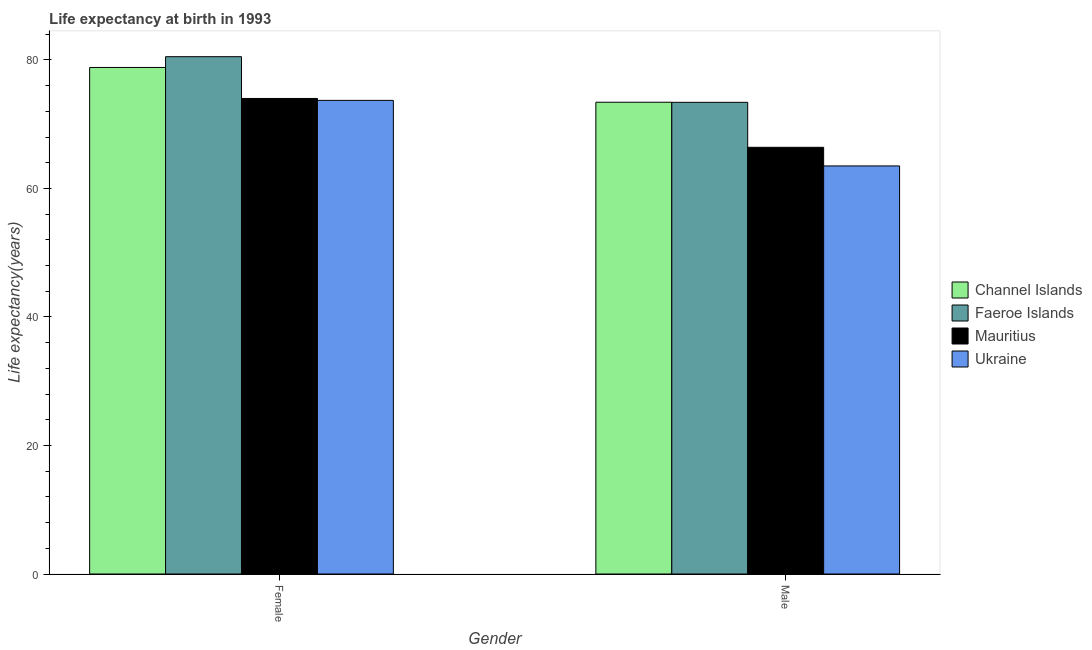How many groups of bars are there?
Your response must be concise. 2. Are the number of bars per tick equal to the number of legend labels?
Your response must be concise. Yes. Are the number of bars on each tick of the X-axis equal?
Offer a very short reply. Yes. How many bars are there on the 1st tick from the left?
Keep it short and to the point. 4. How many bars are there on the 1st tick from the right?
Offer a very short reply. 4. What is the life expectancy(female) in Ukraine?
Your response must be concise. 73.7. Across all countries, what is the maximum life expectancy(female)?
Ensure brevity in your answer.  80.5. Across all countries, what is the minimum life expectancy(female)?
Offer a terse response. 73.7. In which country was the life expectancy(male) maximum?
Give a very brief answer. Channel Islands. In which country was the life expectancy(male) minimum?
Offer a terse response. Ukraine. What is the total life expectancy(male) in the graph?
Keep it short and to the point. 276.71. What is the difference between the life expectancy(male) in Ukraine and that in Faeroe Islands?
Provide a succinct answer. -9.9. What is the difference between the life expectancy(male) in Mauritius and the life expectancy(female) in Channel Islands?
Keep it short and to the point. -12.42. What is the average life expectancy(female) per country?
Provide a succinct answer. 76.76. What is the difference between the life expectancy(female) and life expectancy(male) in Faeroe Islands?
Offer a terse response. 7.1. In how many countries, is the life expectancy(male) greater than 20 years?
Provide a short and direct response. 4. What is the ratio of the life expectancy(female) in Mauritius to that in Ukraine?
Keep it short and to the point. 1. What does the 3rd bar from the left in Male represents?
Make the answer very short. Mauritius. What does the 4th bar from the right in Male represents?
Provide a succinct answer. Channel Islands. How many countries are there in the graph?
Provide a succinct answer. 4. What is the difference between two consecutive major ticks on the Y-axis?
Provide a short and direct response. 20. Are the values on the major ticks of Y-axis written in scientific E-notation?
Provide a succinct answer. No. How many legend labels are there?
Offer a very short reply. 4. How are the legend labels stacked?
Your answer should be compact. Vertical. What is the title of the graph?
Provide a succinct answer. Life expectancy at birth in 1993. What is the label or title of the X-axis?
Ensure brevity in your answer.  Gender. What is the label or title of the Y-axis?
Give a very brief answer. Life expectancy(years). What is the Life expectancy(years) in Channel Islands in Female?
Provide a succinct answer. 78.83. What is the Life expectancy(years) of Faeroe Islands in Female?
Provide a succinct answer. 80.5. What is the Life expectancy(years) in Ukraine in Female?
Give a very brief answer. 73.7. What is the Life expectancy(years) of Channel Islands in Male?
Make the answer very short. 73.41. What is the Life expectancy(years) of Faeroe Islands in Male?
Offer a very short reply. 73.4. What is the Life expectancy(years) in Mauritius in Male?
Your answer should be very brief. 66.4. What is the Life expectancy(years) of Ukraine in Male?
Your response must be concise. 63.5. Across all Gender, what is the maximum Life expectancy(years) of Channel Islands?
Provide a succinct answer. 78.83. Across all Gender, what is the maximum Life expectancy(years) in Faeroe Islands?
Keep it short and to the point. 80.5. Across all Gender, what is the maximum Life expectancy(years) in Ukraine?
Give a very brief answer. 73.7. Across all Gender, what is the minimum Life expectancy(years) of Channel Islands?
Keep it short and to the point. 73.41. Across all Gender, what is the minimum Life expectancy(years) of Faeroe Islands?
Provide a succinct answer. 73.4. Across all Gender, what is the minimum Life expectancy(years) in Mauritius?
Make the answer very short. 66.4. Across all Gender, what is the minimum Life expectancy(years) of Ukraine?
Your response must be concise. 63.5. What is the total Life expectancy(years) of Channel Islands in the graph?
Provide a short and direct response. 152.24. What is the total Life expectancy(years) of Faeroe Islands in the graph?
Keep it short and to the point. 153.9. What is the total Life expectancy(years) in Mauritius in the graph?
Provide a succinct answer. 140.4. What is the total Life expectancy(years) of Ukraine in the graph?
Your response must be concise. 137.2. What is the difference between the Life expectancy(years) of Channel Islands in Female and that in Male?
Keep it short and to the point. 5.41. What is the difference between the Life expectancy(years) in Ukraine in Female and that in Male?
Your answer should be very brief. 10.2. What is the difference between the Life expectancy(years) in Channel Islands in Female and the Life expectancy(years) in Faeroe Islands in Male?
Offer a terse response. 5.42. What is the difference between the Life expectancy(years) of Channel Islands in Female and the Life expectancy(years) of Mauritius in Male?
Your answer should be compact. 12.43. What is the difference between the Life expectancy(years) in Channel Islands in Female and the Life expectancy(years) in Ukraine in Male?
Ensure brevity in your answer.  15.32. What is the average Life expectancy(years) of Channel Islands per Gender?
Your answer should be very brief. 76.12. What is the average Life expectancy(years) of Faeroe Islands per Gender?
Offer a very short reply. 76.95. What is the average Life expectancy(years) of Mauritius per Gender?
Give a very brief answer. 70.2. What is the average Life expectancy(years) of Ukraine per Gender?
Make the answer very short. 68.6. What is the difference between the Life expectancy(years) of Channel Islands and Life expectancy(years) of Faeroe Islands in Female?
Provide a succinct answer. -1.68. What is the difference between the Life expectancy(years) in Channel Islands and Life expectancy(years) in Mauritius in Female?
Provide a short and direct response. 4.83. What is the difference between the Life expectancy(years) of Channel Islands and Life expectancy(years) of Ukraine in Female?
Give a very brief answer. 5.12. What is the difference between the Life expectancy(years) of Faeroe Islands and Life expectancy(years) of Mauritius in Female?
Offer a terse response. 6.5. What is the difference between the Life expectancy(years) of Mauritius and Life expectancy(years) of Ukraine in Female?
Give a very brief answer. 0.3. What is the difference between the Life expectancy(years) in Channel Islands and Life expectancy(years) in Faeroe Islands in Male?
Your answer should be compact. 0.01. What is the difference between the Life expectancy(years) of Channel Islands and Life expectancy(years) of Mauritius in Male?
Offer a terse response. 7.01. What is the difference between the Life expectancy(years) of Channel Islands and Life expectancy(years) of Ukraine in Male?
Give a very brief answer. 9.91. What is the difference between the Life expectancy(years) in Faeroe Islands and Life expectancy(years) in Mauritius in Male?
Your response must be concise. 7. What is the difference between the Life expectancy(years) in Faeroe Islands and Life expectancy(years) in Ukraine in Male?
Make the answer very short. 9.9. What is the difference between the Life expectancy(years) of Mauritius and Life expectancy(years) of Ukraine in Male?
Give a very brief answer. 2.9. What is the ratio of the Life expectancy(years) in Channel Islands in Female to that in Male?
Give a very brief answer. 1.07. What is the ratio of the Life expectancy(years) of Faeroe Islands in Female to that in Male?
Give a very brief answer. 1.1. What is the ratio of the Life expectancy(years) in Mauritius in Female to that in Male?
Offer a very short reply. 1.11. What is the ratio of the Life expectancy(years) in Ukraine in Female to that in Male?
Your response must be concise. 1.16. What is the difference between the highest and the second highest Life expectancy(years) in Channel Islands?
Keep it short and to the point. 5.41. What is the difference between the highest and the second highest Life expectancy(years) in Faeroe Islands?
Offer a terse response. 7.1. What is the difference between the highest and the second highest Life expectancy(years) in Mauritius?
Offer a very short reply. 7.6. What is the difference between the highest and the second highest Life expectancy(years) of Ukraine?
Offer a terse response. 10.2. What is the difference between the highest and the lowest Life expectancy(years) in Channel Islands?
Your response must be concise. 5.41. What is the difference between the highest and the lowest Life expectancy(years) of Mauritius?
Make the answer very short. 7.6. 